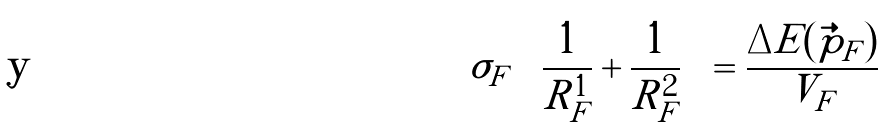<formula> <loc_0><loc_0><loc_500><loc_500>\sigma _ { F } \left ( \frac { 1 } { R ^ { 1 } _ { F } } + \frac { 1 } { R ^ { 2 } _ { F } } \right ) = \frac { \Delta E ( \vec { p } _ { F } ) } { V _ { F } }</formula> 